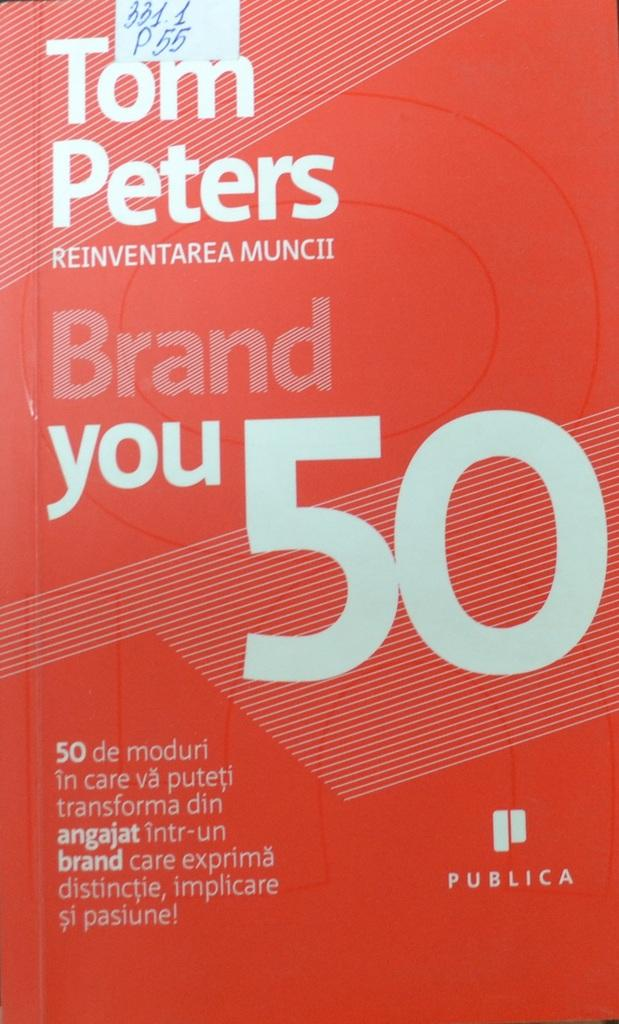<image>
Summarize the visual content of the image. Red booklet with the name Tom Peters on the top. 